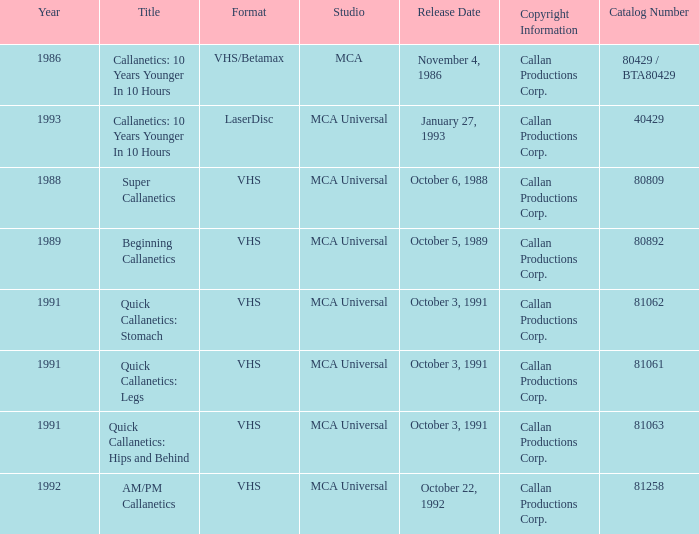Indicate the layout for super callanetics VHS. 